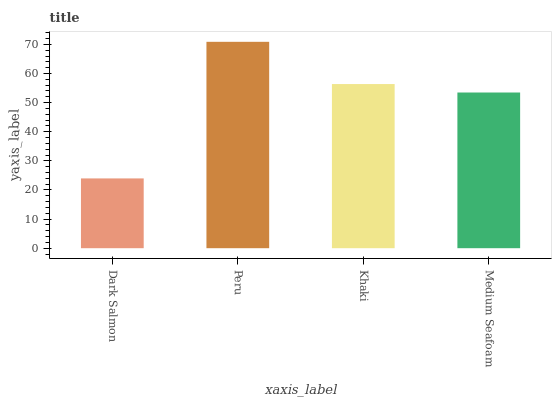Is Dark Salmon the minimum?
Answer yes or no. Yes. Is Peru the maximum?
Answer yes or no. Yes. Is Khaki the minimum?
Answer yes or no. No. Is Khaki the maximum?
Answer yes or no. No. Is Peru greater than Khaki?
Answer yes or no. Yes. Is Khaki less than Peru?
Answer yes or no. Yes. Is Khaki greater than Peru?
Answer yes or no. No. Is Peru less than Khaki?
Answer yes or no. No. Is Khaki the high median?
Answer yes or no. Yes. Is Medium Seafoam the low median?
Answer yes or no. Yes. Is Peru the high median?
Answer yes or no. No. Is Peru the low median?
Answer yes or no. No. 